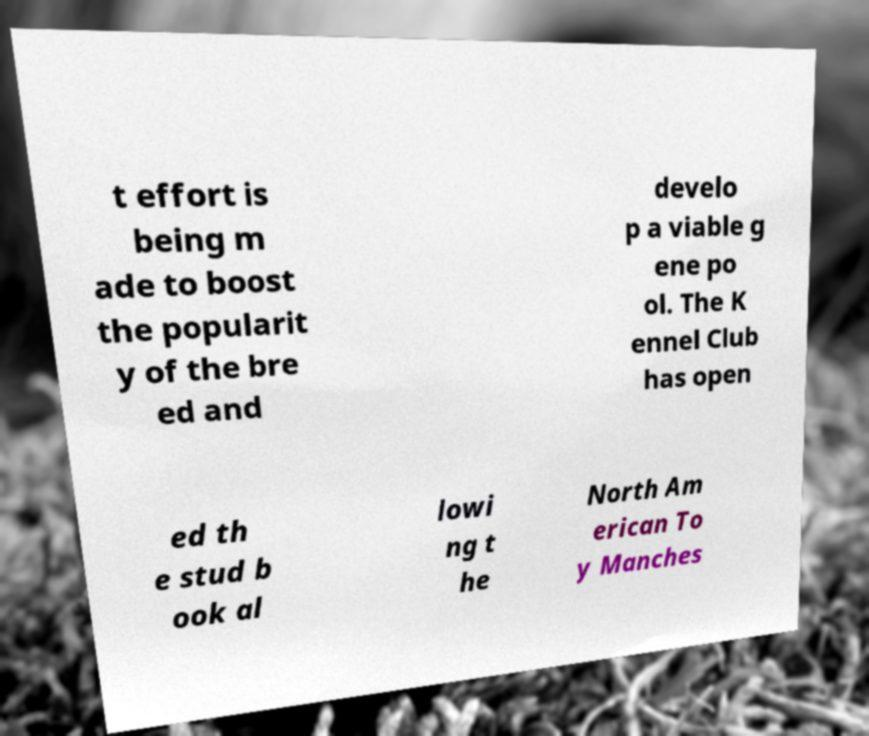I need the written content from this picture converted into text. Can you do that? t effort is being m ade to boost the popularit y of the bre ed and develo p a viable g ene po ol. The K ennel Club has open ed th e stud b ook al lowi ng t he North Am erican To y Manches 